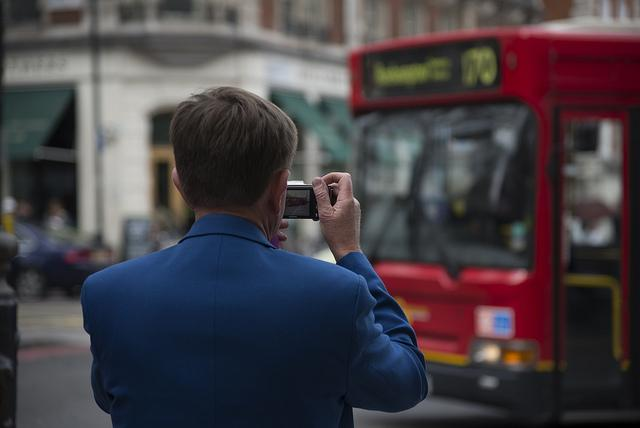What is the person in blue coat doing? Please explain your reasoning. taking photo. The person in the blue coat has his camera on and pointed at the red bus.  the bus can be seen in view on the screen. 